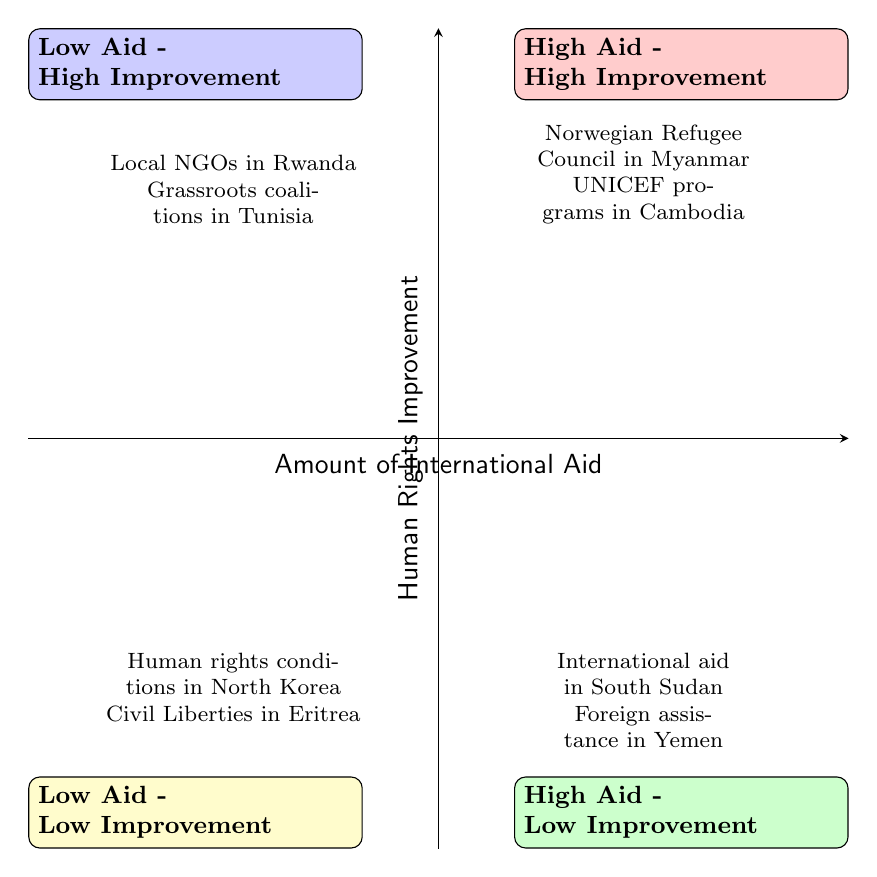What are the examples in the High Aid - High Improvement quadrant? The diagram specifies the examples for the High Aid - High Improvement quadrant, showing "Norwegian Refugee Council in Myanmar" and "UNICEF programs in Cambodia." These examples are provided within the section designated for this quadrant.
Answer: Norwegian Refugee Council in Myanmar, UNICEF programs in Cambodia Which quadrant represents Low Aid and High Improvement? In the diagram, the quadrant that represents Low Aid and High Improvement is labeled clearly as Low Aid - High Improvement, and it lists examples indicating this category.
Answer: Low Aid - High Improvement How many examples are provided for the High Aid - Low Improvement quadrant? The diagram illustrates the High Aid - Low Improvement quadrant, which contains two examples: "International aid in South Sudan" and "Foreign assistance in Yemen." This indicates that there are two examples for this quadrant.
Answer: 2 What is one example listed in the Low Aid - Low Improvement quadrant? According to the diagram, one example provided for the Low Aid - Low Improvement quadrant is "Human rights conditions in North Korea." This is one of the specific instances cited in the quadrant.
Answer: Human rights conditions in North Korea Which quadrant has Local NGOs in Rwanda as an example? The diagram places "Local NGOs in Rwanda" as an example in the Low Aid - High Improvement quadrant. This illustrates the site of such examples effectively within this categorical structure.
Answer: Low Aid - High Improvement 